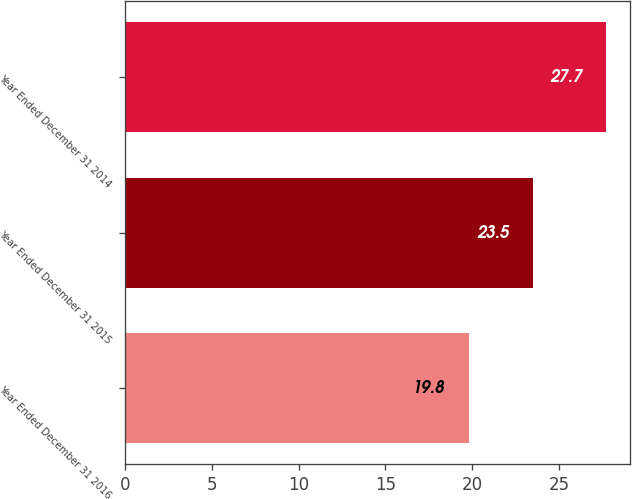Convert chart to OTSL. <chart><loc_0><loc_0><loc_500><loc_500><bar_chart><fcel>Year Ended December 31 2016<fcel>Year Ended December 31 2015<fcel>Year Ended December 31 2014<nl><fcel>19.8<fcel>23.5<fcel>27.7<nl></chart> 